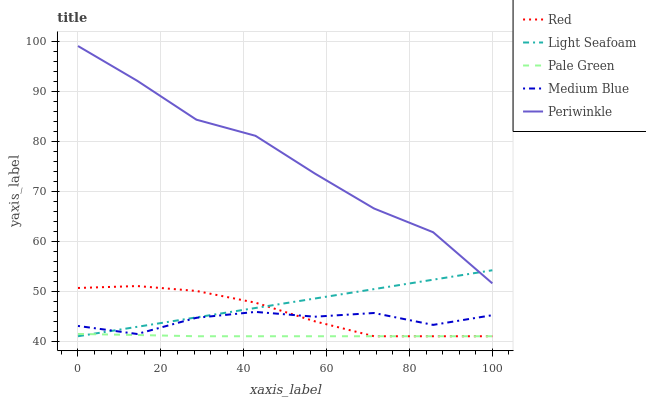Does Pale Green have the minimum area under the curve?
Answer yes or no. Yes. Does Periwinkle have the maximum area under the curve?
Answer yes or no. Yes. Does Light Seafoam have the minimum area under the curve?
Answer yes or no. No. Does Light Seafoam have the maximum area under the curve?
Answer yes or no. No. Is Light Seafoam the smoothest?
Answer yes or no. Yes. Is Medium Blue the roughest?
Answer yes or no. Yes. Is Periwinkle the smoothest?
Answer yes or no. No. Is Periwinkle the roughest?
Answer yes or no. No. Does Pale Green have the lowest value?
Answer yes or no. Yes. Does Periwinkle have the lowest value?
Answer yes or no. No. Does Periwinkle have the highest value?
Answer yes or no. Yes. Does Light Seafoam have the highest value?
Answer yes or no. No. Is Medium Blue less than Periwinkle?
Answer yes or no. Yes. Is Periwinkle greater than Pale Green?
Answer yes or no. Yes. Does Medium Blue intersect Light Seafoam?
Answer yes or no. Yes. Is Medium Blue less than Light Seafoam?
Answer yes or no. No. Is Medium Blue greater than Light Seafoam?
Answer yes or no. No. Does Medium Blue intersect Periwinkle?
Answer yes or no. No. 